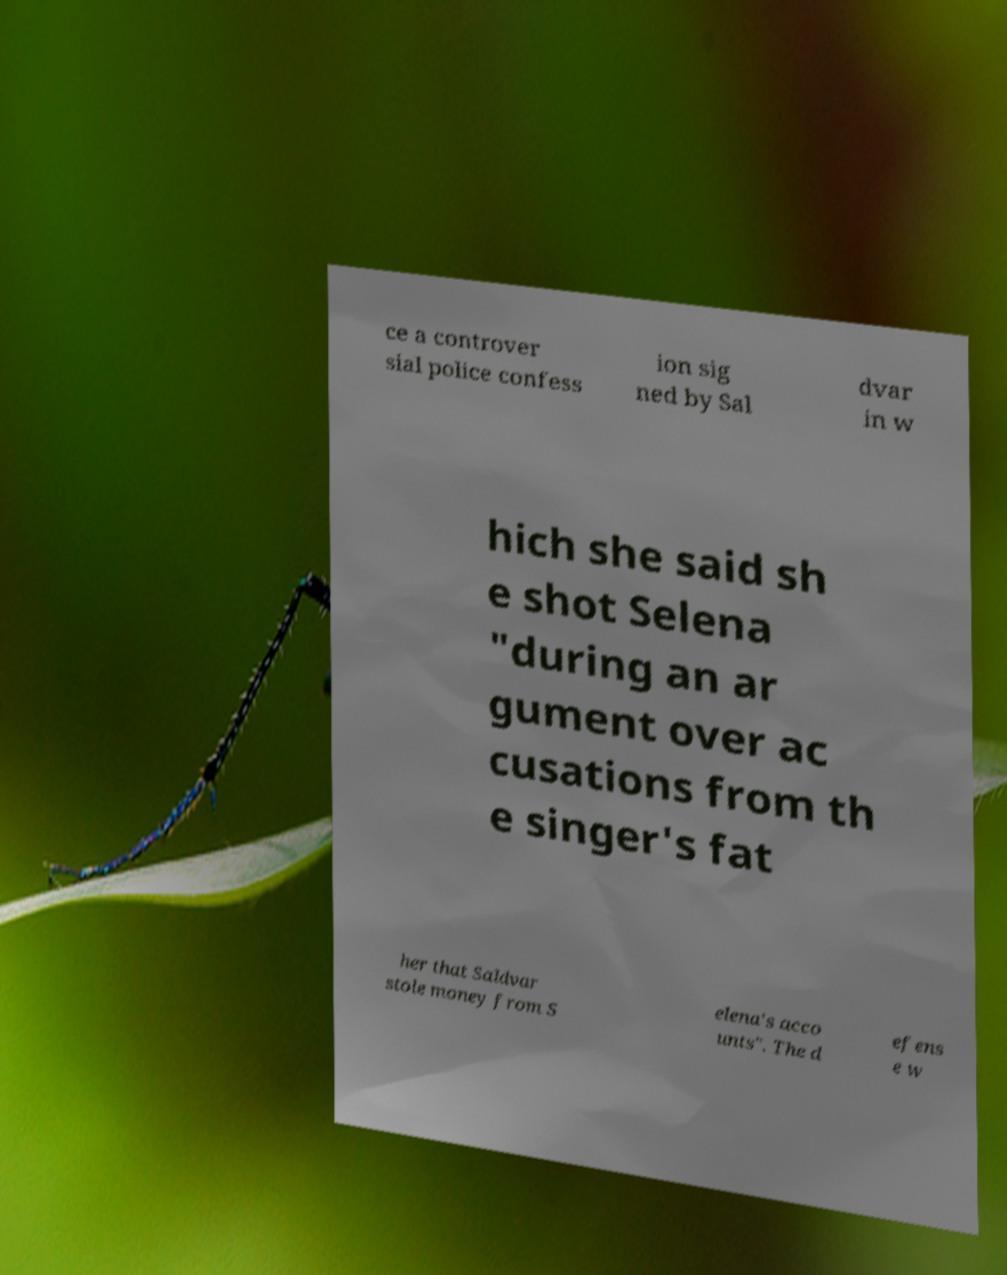Could you extract and type out the text from this image? ce a controver sial police confess ion sig ned by Sal dvar in w hich she said sh e shot Selena "during an ar gument over ac cusations from th e singer's fat her that Saldvar stole money from S elena's acco unts". The d efens e w 